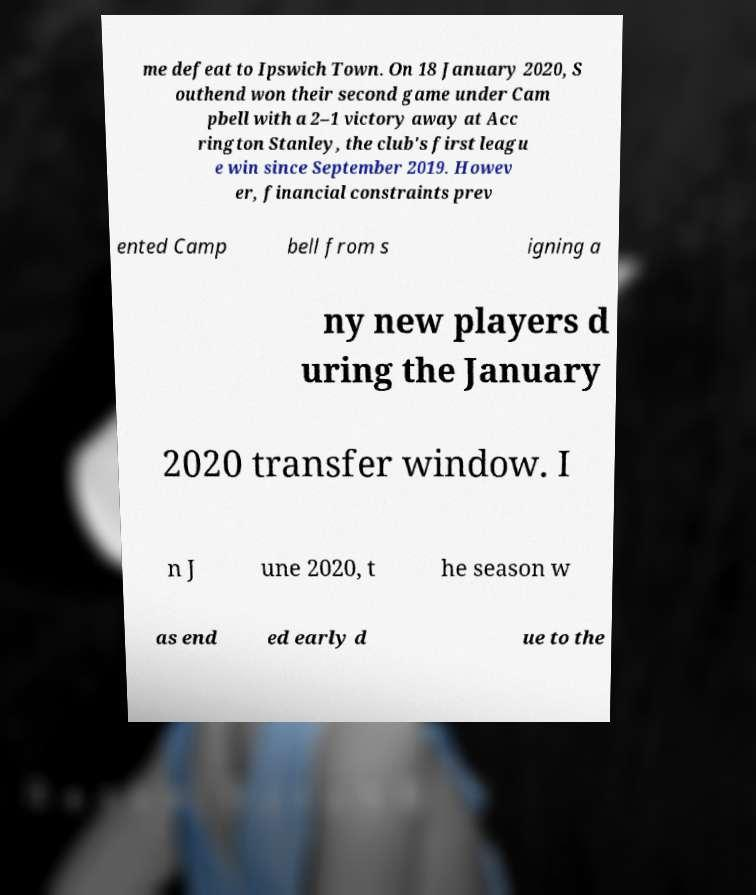What messages or text are displayed in this image? I need them in a readable, typed format. me defeat to Ipswich Town. On 18 January 2020, S outhend won their second game under Cam pbell with a 2–1 victory away at Acc rington Stanley, the club's first leagu e win since September 2019. Howev er, financial constraints prev ented Camp bell from s igning a ny new players d uring the January 2020 transfer window. I n J une 2020, t he season w as end ed early d ue to the 